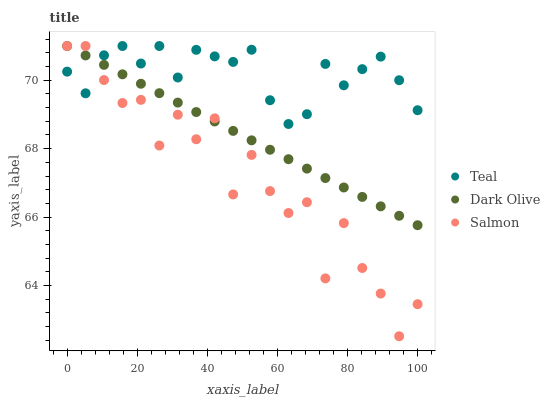Does Salmon have the minimum area under the curve?
Answer yes or no. Yes. Does Teal have the maximum area under the curve?
Answer yes or no. Yes. Does Teal have the minimum area under the curve?
Answer yes or no. No. Does Salmon have the maximum area under the curve?
Answer yes or no. No. Is Dark Olive the smoothest?
Answer yes or no. Yes. Is Salmon the roughest?
Answer yes or no. Yes. Is Teal the smoothest?
Answer yes or no. No. Is Teal the roughest?
Answer yes or no. No. Does Salmon have the lowest value?
Answer yes or no. Yes. Does Teal have the lowest value?
Answer yes or no. No. Does Teal have the highest value?
Answer yes or no. Yes. Does Dark Olive intersect Teal?
Answer yes or no. Yes. Is Dark Olive less than Teal?
Answer yes or no. No. Is Dark Olive greater than Teal?
Answer yes or no. No. 